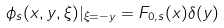<formula> <loc_0><loc_0><loc_500><loc_500>\phi _ { s } ( x , y , \xi ) | _ { \xi = - y } = F _ { 0 , s } ( x ) \delta ( y )</formula> 